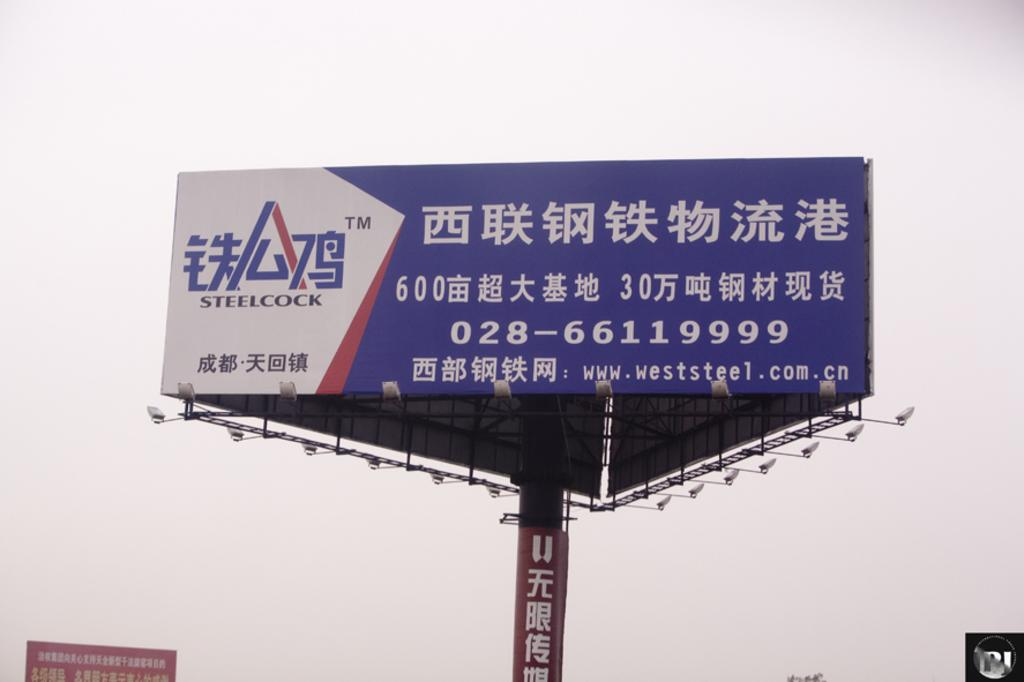<image>
Give a short and clear explanation of the subsequent image. a large blue and white billboard featuring steelcock written in mandarin. 